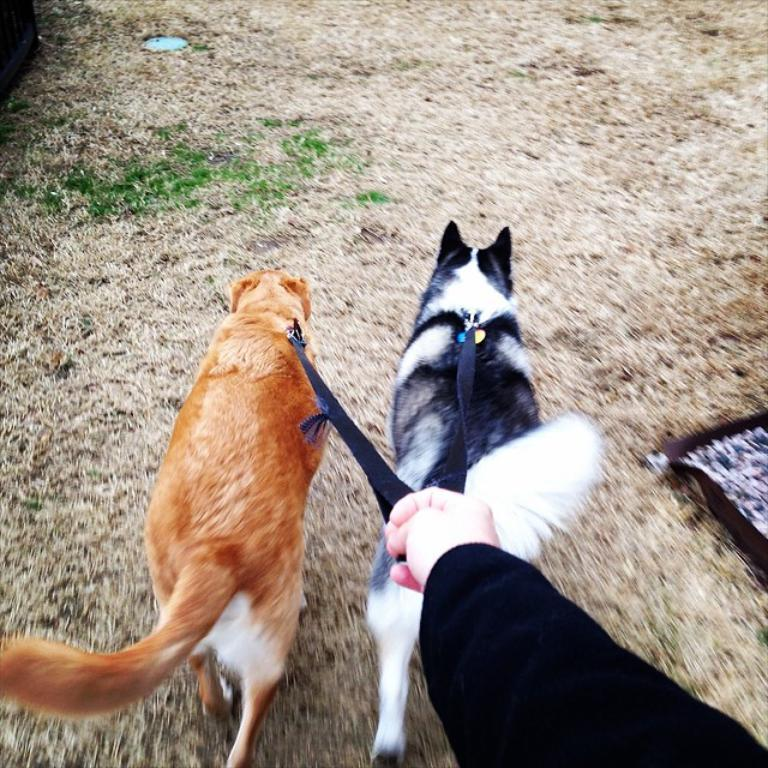How many dogs are present in the image? There are two dogs in the image. What are the dogs doing in the image? The dogs are walking on the ground. Is there anyone with the dogs in the image? Yes, there is a person holding a dog rope chain in the image. What type of cushion is being used by the bear in the image? There is no bear or cushion present in the image; it features two dogs and a person holding a dog rope chain. 